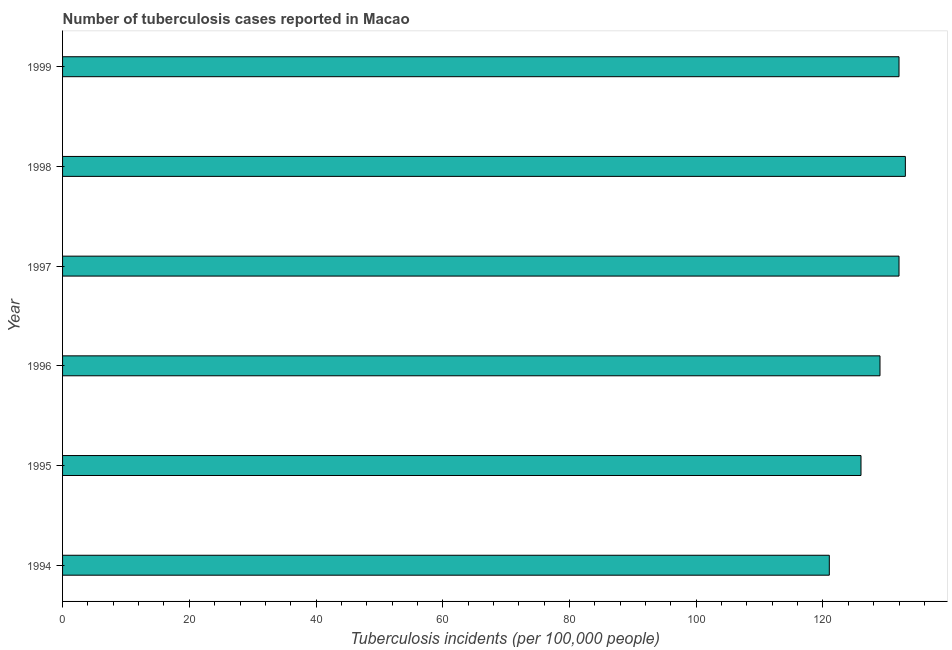Does the graph contain any zero values?
Provide a short and direct response. No. What is the title of the graph?
Provide a succinct answer. Number of tuberculosis cases reported in Macao. What is the label or title of the X-axis?
Offer a terse response. Tuberculosis incidents (per 100,0 people). What is the number of tuberculosis incidents in 1995?
Your answer should be compact. 126. Across all years, what is the maximum number of tuberculosis incidents?
Ensure brevity in your answer.  133. Across all years, what is the minimum number of tuberculosis incidents?
Ensure brevity in your answer.  121. In which year was the number of tuberculosis incidents minimum?
Your answer should be very brief. 1994. What is the sum of the number of tuberculosis incidents?
Your response must be concise. 773. What is the difference between the number of tuberculosis incidents in 1996 and 1999?
Provide a succinct answer. -3. What is the average number of tuberculosis incidents per year?
Offer a very short reply. 128. What is the median number of tuberculosis incidents?
Make the answer very short. 130.5. In how many years, is the number of tuberculosis incidents greater than 100 ?
Offer a very short reply. 6. Do a majority of the years between 1999 and 1996 (inclusive) have number of tuberculosis incidents greater than 20 ?
Your response must be concise. Yes. What is the ratio of the number of tuberculosis incidents in 1994 to that in 1996?
Keep it short and to the point. 0.94. Is the number of tuberculosis incidents in 1994 less than that in 1999?
Your answer should be very brief. Yes. Is the difference between the number of tuberculosis incidents in 1994 and 1999 greater than the difference between any two years?
Make the answer very short. No. Is the sum of the number of tuberculosis incidents in 1995 and 1996 greater than the maximum number of tuberculosis incidents across all years?
Your answer should be very brief. Yes. What is the difference between the highest and the lowest number of tuberculosis incidents?
Provide a succinct answer. 12. In how many years, is the number of tuberculosis incidents greater than the average number of tuberculosis incidents taken over all years?
Make the answer very short. 4. How many bars are there?
Give a very brief answer. 6. How many years are there in the graph?
Your response must be concise. 6. What is the difference between two consecutive major ticks on the X-axis?
Make the answer very short. 20. What is the Tuberculosis incidents (per 100,000 people) of 1994?
Make the answer very short. 121. What is the Tuberculosis incidents (per 100,000 people) in 1995?
Give a very brief answer. 126. What is the Tuberculosis incidents (per 100,000 people) in 1996?
Offer a terse response. 129. What is the Tuberculosis incidents (per 100,000 people) in 1997?
Your response must be concise. 132. What is the Tuberculosis incidents (per 100,000 people) of 1998?
Your answer should be very brief. 133. What is the Tuberculosis incidents (per 100,000 people) in 1999?
Keep it short and to the point. 132. What is the difference between the Tuberculosis incidents (per 100,000 people) in 1994 and 1995?
Make the answer very short. -5. What is the difference between the Tuberculosis incidents (per 100,000 people) in 1994 and 1997?
Make the answer very short. -11. What is the difference between the Tuberculosis incidents (per 100,000 people) in 1994 and 1998?
Your response must be concise. -12. What is the difference between the Tuberculosis incidents (per 100,000 people) in 1995 and 1997?
Offer a terse response. -6. What is the difference between the Tuberculosis incidents (per 100,000 people) in 1996 and 1997?
Ensure brevity in your answer.  -3. What is the difference between the Tuberculosis incidents (per 100,000 people) in 1996 and 1998?
Your answer should be compact. -4. What is the difference between the Tuberculosis incidents (per 100,000 people) in 1997 and 1998?
Your response must be concise. -1. What is the difference between the Tuberculosis incidents (per 100,000 people) in 1997 and 1999?
Give a very brief answer. 0. What is the ratio of the Tuberculosis incidents (per 100,000 people) in 1994 to that in 1995?
Your answer should be very brief. 0.96. What is the ratio of the Tuberculosis incidents (per 100,000 people) in 1994 to that in 1996?
Give a very brief answer. 0.94. What is the ratio of the Tuberculosis incidents (per 100,000 people) in 1994 to that in 1997?
Your answer should be compact. 0.92. What is the ratio of the Tuberculosis incidents (per 100,000 people) in 1994 to that in 1998?
Keep it short and to the point. 0.91. What is the ratio of the Tuberculosis incidents (per 100,000 people) in 1994 to that in 1999?
Your answer should be very brief. 0.92. What is the ratio of the Tuberculosis incidents (per 100,000 people) in 1995 to that in 1996?
Give a very brief answer. 0.98. What is the ratio of the Tuberculosis incidents (per 100,000 people) in 1995 to that in 1997?
Keep it short and to the point. 0.95. What is the ratio of the Tuberculosis incidents (per 100,000 people) in 1995 to that in 1998?
Provide a short and direct response. 0.95. What is the ratio of the Tuberculosis incidents (per 100,000 people) in 1995 to that in 1999?
Your response must be concise. 0.95. What is the ratio of the Tuberculosis incidents (per 100,000 people) in 1996 to that in 1997?
Offer a very short reply. 0.98. What is the ratio of the Tuberculosis incidents (per 100,000 people) in 1997 to that in 1998?
Your answer should be very brief. 0.99. What is the ratio of the Tuberculosis incidents (per 100,000 people) in 1997 to that in 1999?
Your response must be concise. 1. What is the ratio of the Tuberculosis incidents (per 100,000 people) in 1998 to that in 1999?
Your response must be concise. 1.01. 